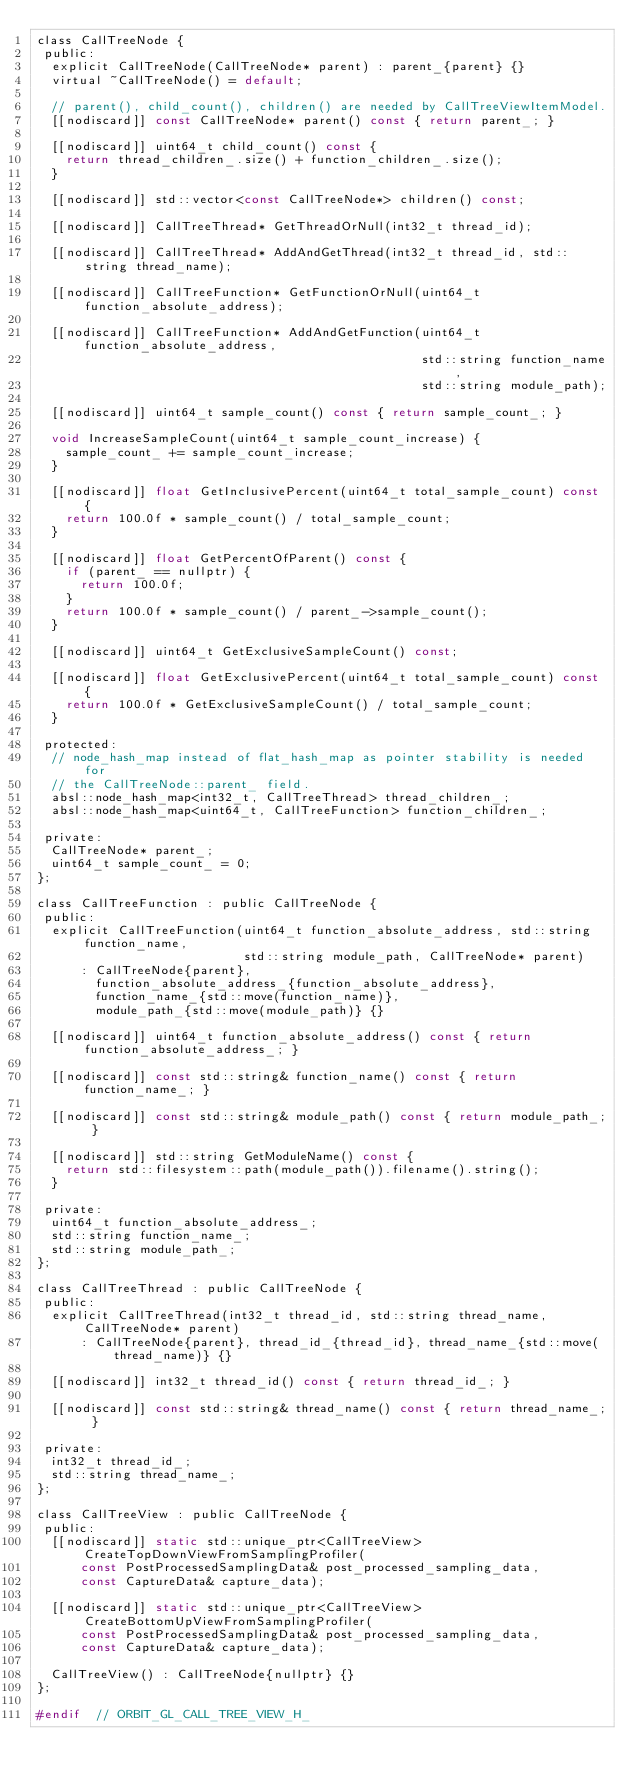<code> <loc_0><loc_0><loc_500><loc_500><_C_>class CallTreeNode {
 public:
  explicit CallTreeNode(CallTreeNode* parent) : parent_{parent} {}
  virtual ~CallTreeNode() = default;

  // parent(), child_count(), children() are needed by CallTreeViewItemModel.
  [[nodiscard]] const CallTreeNode* parent() const { return parent_; }

  [[nodiscard]] uint64_t child_count() const {
    return thread_children_.size() + function_children_.size();
  }

  [[nodiscard]] std::vector<const CallTreeNode*> children() const;

  [[nodiscard]] CallTreeThread* GetThreadOrNull(int32_t thread_id);

  [[nodiscard]] CallTreeThread* AddAndGetThread(int32_t thread_id, std::string thread_name);

  [[nodiscard]] CallTreeFunction* GetFunctionOrNull(uint64_t function_absolute_address);

  [[nodiscard]] CallTreeFunction* AddAndGetFunction(uint64_t function_absolute_address,
                                                    std::string function_name,
                                                    std::string module_path);

  [[nodiscard]] uint64_t sample_count() const { return sample_count_; }

  void IncreaseSampleCount(uint64_t sample_count_increase) {
    sample_count_ += sample_count_increase;
  }

  [[nodiscard]] float GetInclusivePercent(uint64_t total_sample_count) const {
    return 100.0f * sample_count() / total_sample_count;
  }

  [[nodiscard]] float GetPercentOfParent() const {
    if (parent_ == nullptr) {
      return 100.0f;
    }
    return 100.0f * sample_count() / parent_->sample_count();
  }

  [[nodiscard]] uint64_t GetExclusiveSampleCount() const;

  [[nodiscard]] float GetExclusivePercent(uint64_t total_sample_count) const {
    return 100.0f * GetExclusiveSampleCount() / total_sample_count;
  }

 protected:
  // node_hash_map instead of flat_hash_map as pointer stability is needed for
  // the CallTreeNode::parent_ field.
  absl::node_hash_map<int32_t, CallTreeThread> thread_children_;
  absl::node_hash_map<uint64_t, CallTreeFunction> function_children_;

 private:
  CallTreeNode* parent_;
  uint64_t sample_count_ = 0;
};

class CallTreeFunction : public CallTreeNode {
 public:
  explicit CallTreeFunction(uint64_t function_absolute_address, std::string function_name,
                            std::string module_path, CallTreeNode* parent)
      : CallTreeNode{parent},
        function_absolute_address_{function_absolute_address},
        function_name_{std::move(function_name)},
        module_path_{std::move(module_path)} {}

  [[nodiscard]] uint64_t function_absolute_address() const { return function_absolute_address_; }

  [[nodiscard]] const std::string& function_name() const { return function_name_; }

  [[nodiscard]] const std::string& module_path() const { return module_path_; }

  [[nodiscard]] std::string GetModuleName() const {
    return std::filesystem::path(module_path()).filename().string();
  }

 private:
  uint64_t function_absolute_address_;
  std::string function_name_;
  std::string module_path_;
};

class CallTreeThread : public CallTreeNode {
 public:
  explicit CallTreeThread(int32_t thread_id, std::string thread_name, CallTreeNode* parent)
      : CallTreeNode{parent}, thread_id_{thread_id}, thread_name_{std::move(thread_name)} {}

  [[nodiscard]] int32_t thread_id() const { return thread_id_; }

  [[nodiscard]] const std::string& thread_name() const { return thread_name_; }

 private:
  int32_t thread_id_;
  std::string thread_name_;
};

class CallTreeView : public CallTreeNode {
 public:
  [[nodiscard]] static std::unique_ptr<CallTreeView> CreateTopDownViewFromSamplingProfiler(
      const PostProcessedSamplingData& post_processed_sampling_data,
      const CaptureData& capture_data);

  [[nodiscard]] static std::unique_ptr<CallTreeView> CreateBottomUpViewFromSamplingProfiler(
      const PostProcessedSamplingData& post_processed_sampling_data,
      const CaptureData& capture_data);

  CallTreeView() : CallTreeNode{nullptr} {}
};

#endif  // ORBIT_GL_CALL_TREE_VIEW_H_
</code> 